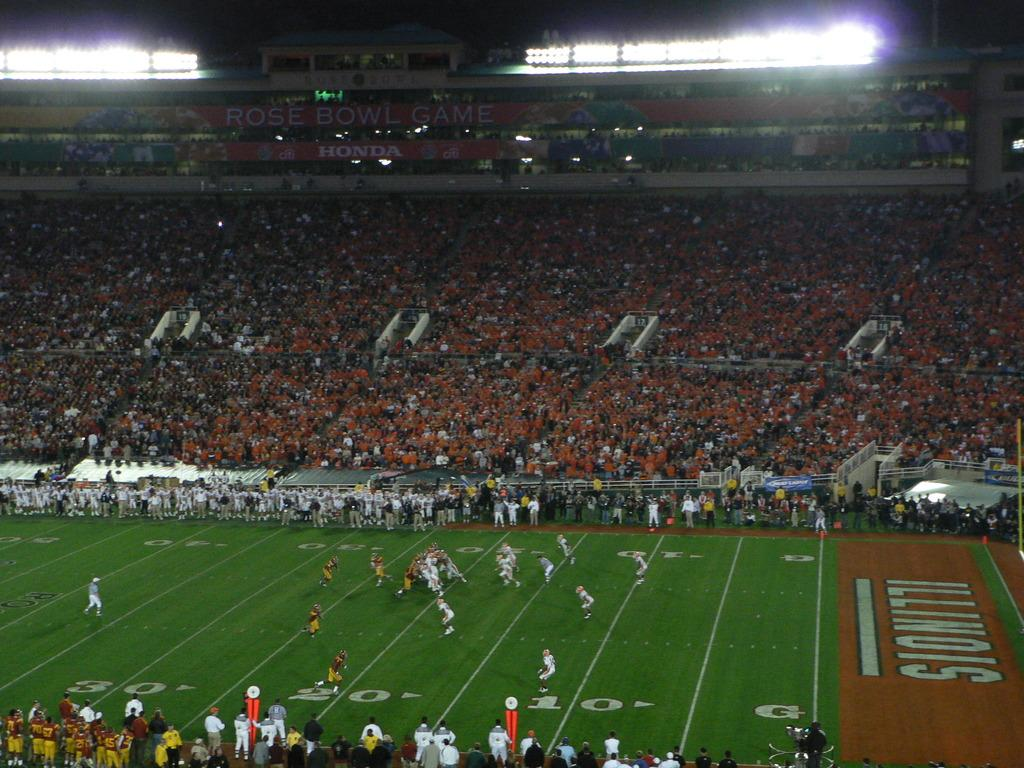<image>
Render a clear and concise summary of the photo. A football game is being played with a large crowd on Illinois field 